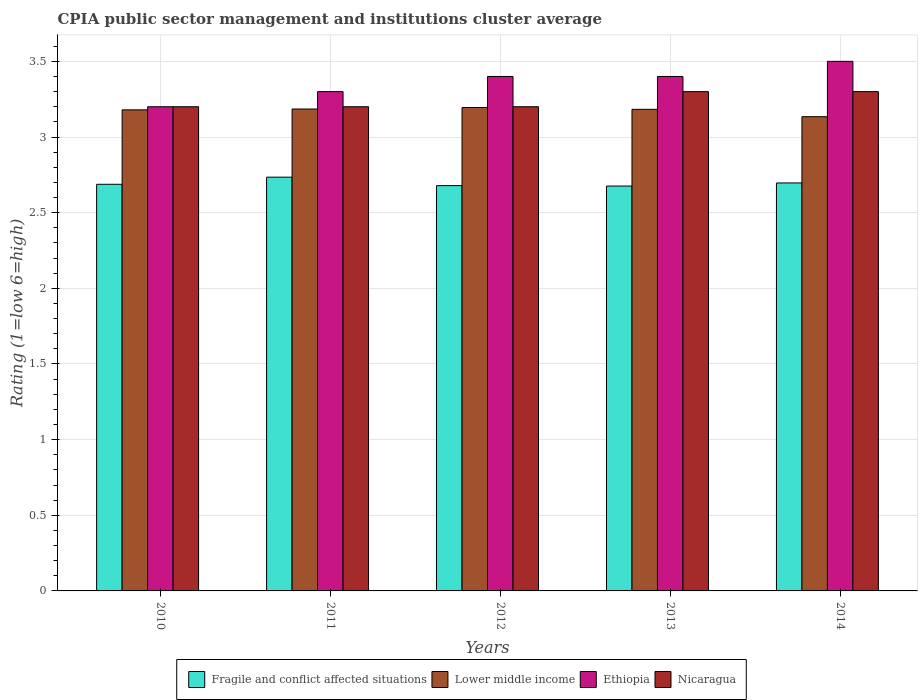How many different coloured bars are there?
Offer a very short reply. 4. How many groups of bars are there?
Offer a terse response. 5. Are the number of bars on each tick of the X-axis equal?
Your answer should be very brief. Yes. What is the CPIA rating in Fragile and conflict affected situations in 2011?
Provide a succinct answer. 2.73. In which year was the CPIA rating in Ethiopia minimum?
Your answer should be very brief. 2010. What is the total CPIA rating in Fragile and conflict affected situations in the graph?
Make the answer very short. 13.47. What is the difference between the CPIA rating in Lower middle income in 2010 and that in 2011?
Your answer should be compact. -0.01. What is the difference between the CPIA rating in Lower middle income in 2014 and the CPIA rating in Fragile and conflict affected situations in 2013?
Your answer should be very brief. 0.46. What is the average CPIA rating in Lower middle income per year?
Provide a short and direct response. 3.18. In the year 2012, what is the difference between the CPIA rating in Fragile and conflict affected situations and CPIA rating in Ethiopia?
Your answer should be very brief. -0.72. In how many years, is the CPIA rating in Ethiopia greater than 2.5?
Provide a short and direct response. 5. What is the ratio of the CPIA rating in Ethiopia in 2011 to that in 2014?
Offer a very short reply. 0.94. Is the CPIA rating in Lower middle income in 2010 less than that in 2013?
Provide a succinct answer. Yes. What is the difference between the highest and the lowest CPIA rating in Nicaragua?
Your response must be concise. 0.1. What does the 4th bar from the left in 2010 represents?
Make the answer very short. Nicaragua. What does the 4th bar from the right in 2012 represents?
Give a very brief answer. Fragile and conflict affected situations. Is it the case that in every year, the sum of the CPIA rating in Fragile and conflict affected situations and CPIA rating in Nicaragua is greater than the CPIA rating in Ethiopia?
Your answer should be very brief. Yes. How many years are there in the graph?
Keep it short and to the point. 5. Are the values on the major ticks of Y-axis written in scientific E-notation?
Provide a succinct answer. No. Does the graph contain grids?
Your answer should be compact. Yes. Where does the legend appear in the graph?
Offer a very short reply. Bottom center. How are the legend labels stacked?
Ensure brevity in your answer.  Horizontal. What is the title of the graph?
Your response must be concise. CPIA public sector management and institutions cluster average. What is the label or title of the X-axis?
Offer a terse response. Years. What is the Rating (1=low 6=high) of Fragile and conflict affected situations in 2010?
Give a very brief answer. 2.69. What is the Rating (1=low 6=high) of Lower middle income in 2010?
Offer a terse response. 3.18. What is the Rating (1=low 6=high) of Ethiopia in 2010?
Offer a terse response. 3.2. What is the Rating (1=low 6=high) of Nicaragua in 2010?
Your answer should be very brief. 3.2. What is the Rating (1=low 6=high) in Fragile and conflict affected situations in 2011?
Offer a very short reply. 2.73. What is the Rating (1=low 6=high) in Lower middle income in 2011?
Provide a short and direct response. 3.19. What is the Rating (1=low 6=high) of Ethiopia in 2011?
Your answer should be very brief. 3.3. What is the Rating (1=low 6=high) of Fragile and conflict affected situations in 2012?
Keep it short and to the point. 2.68. What is the Rating (1=low 6=high) of Lower middle income in 2012?
Give a very brief answer. 3.19. What is the Rating (1=low 6=high) of Nicaragua in 2012?
Your answer should be very brief. 3.2. What is the Rating (1=low 6=high) of Fragile and conflict affected situations in 2013?
Your answer should be very brief. 2.68. What is the Rating (1=low 6=high) of Lower middle income in 2013?
Ensure brevity in your answer.  3.18. What is the Rating (1=low 6=high) of Ethiopia in 2013?
Your answer should be very brief. 3.4. What is the Rating (1=low 6=high) in Fragile and conflict affected situations in 2014?
Your answer should be very brief. 2.7. What is the Rating (1=low 6=high) in Lower middle income in 2014?
Provide a succinct answer. 3.13. What is the Rating (1=low 6=high) of Ethiopia in 2014?
Keep it short and to the point. 3.5. Across all years, what is the maximum Rating (1=low 6=high) in Fragile and conflict affected situations?
Your response must be concise. 2.73. Across all years, what is the maximum Rating (1=low 6=high) in Lower middle income?
Offer a very short reply. 3.19. Across all years, what is the maximum Rating (1=low 6=high) of Ethiopia?
Provide a succinct answer. 3.5. Across all years, what is the maximum Rating (1=low 6=high) in Nicaragua?
Make the answer very short. 3.3. Across all years, what is the minimum Rating (1=low 6=high) of Fragile and conflict affected situations?
Give a very brief answer. 2.68. Across all years, what is the minimum Rating (1=low 6=high) of Lower middle income?
Your answer should be very brief. 3.13. Across all years, what is the minimum Rating (1=low 6=high) in Ethiopia?
Give a very brief answer. 3.2. What is the total Rating (1=low 6=high) of Fragile and conflict affected situations in the graph?
Ensure brevity in your answer.  13.47. What is the total Rating (1=low 6=high) in Lower middle income in the graph?
Give a very brief answer. 15.88. What is the total Rating (1=low 6=high) of Ethiopia in the graph?
Provide a short and direct response. 16.8. What is the total Rating (1=low 6=high) in Nicaragua in the graph?
Your answer should be compact. 16.2. What is the difference between the Rating (1=low 6=high) of Fragile and conflict affected situations in 2010 and that in 2011?
Your answer should be compact. -0.05. What is the difference between the Rating (1=low 6=high) of Lower middle income in 2010 and that in 2011?
Offer a terse response. -0.01. What is the difference between the Rating (1=low 6=high) in Ethiopia in 2010 and that in 2011?
Offer a very short reply. -0.1. What is the difference between the Rating (1=low 6=high) in Nicaragua in 2010 and that in 2011?
Your answer should be compact. 0. What is the difference between the Rating (1=low 6=high) of Fragile and conflict affected situations in 2010 and that in 2012?
Your answer should be very brief. 0.01. What is the difference between the Rating (1=low 6=high) of Lower middle income in 2010 and that in 2012?
Your response must be concise. -0.02. What is the difference between the Rating (1=low 6=high) in Ethiopia in 2010 and that in 2012?
Make the answer very short. -0.2. What is the difference between the Rating (1=low 6=high) in Fragile and conflict affected situations in 2010 and that in 2013?
Your response must be concise. 0.01. What is the difference between the Rating (1=low 6=high) of Lower middle income in 2010 and that in 2013?
Your answer should be very brief. -0. What is the difference between the Rating (1=low 6=high) in Ethiopia in 2010 and that in 2013?
Your response must be concise. -0.2. What is the difference between the Rating (1=low 6=high) of Fragile and conflict affected situations in 2010 and that in 2014?
Your answer should be very brief. -0.01. What is the difference between the Rating (1=low 6=high) in Lower middle income in 2010 and that in 2014?
Ensure brevity in your answer.  0.05. What is the difference between the Rating (1=low 6=high) in Ethiopia in 2010 and that in 2014?
Keep it short and to the point. -0.3. What is the difference between the Rating (1=low 6=high) in Nicaragua in 2010 and that in 2014?
Provide a short and direct response. -0.1. What is the difference between the Rating (1=low 6=high) in Fragile and conflict affected situations in 2011 and that in 2012?
Your response must be concise. 0.06. What is the difference between the Rating (1=low 6=high) in Lower middle income in 2011 and that in 2012?
Offer a terse response. -0.01. What is the difference between the Rating (1=low 6=high) in Nicaragua in 2011 and that in 2012?
Your answer should be compact. 0. What is the difference between the Rating (1=low 6=high) in Fragile and conflict affected situations in 2011 and that in 2013?
Offer a very short reply. 0.06. What is the difference between the Rating (1=low 6=high) in Lower middle income in 2011 and that in 2013?
Provide a short and direct response. 0. What is the difference between the Rating (1=low 6=high) of Fragile and conflict affected situations in 2011 and that in 2014?
Offer a very short reply. 0.04. What is the difference between the Rating (1=low 6=high) of Lower middle income in 2011 and that in 2014?
Your response must be concise. 0.05. What is the difference between the Rating (1=low 6=high) in Ethiopia in 2011 and that in 2014?
Your answer should be compact. -0.2. What is the difference between the Rating (1=low 6=high) in Nicaragua in 2011 and that in 2014?
Give a very brief answer. -0.1. What is the difference between the Rating (1=low 6=high) in Fragile and conflict affected situations in 2012 and that in 2013?
Your answer should be compact. 0. What is the difference between the Rating (1=low 6=high) of Lower middle income in 2012 and that in 2013?
Offer a terse response. 0.01. What is the difference between the Rating (1=low 6=high) of Ethiopia in 2012 and that in 2013?
Your response must be concise. 0. What is the difference between the Rating (1=low 6=high) in Fragile and conflict affected situations in 2012 and that in 2014?
Your answer should be very brief. -0.02. What is the difference between the Rating (1=low 6=high) of Lower middle income in 2012 and that in 2014?
Your answer should be very brief. 0.06. What is the difference between the Rating (1=low 6=high) of Nicaragua in 2012 and that in 2014?
Provide a succinct answer. -0.1. What is the difference between the Rating (1=low 6=high) of Fragile and conflict affected situations in 2013 and that in 2014?
Ensure brevity in your answer.  -0.02. What is the difference between the Rating (1=low 6=high) in Lower middle income in 2013 and that in 2014?
Provide a short and direct response. 0.05. What is the difference between the Rating (1=low 6=high) in Ethiopia in 2013 and that in 2014?
Provide a succinct answer. -0.1. What is the difference between the Rating (1=low 6=high) of Fragile and conflict affected situations in 2010 and the Rating (1=low 6=high) of Lower middle income in 2011?
Your answer should be compact. -0.5. What is the difference between the Rating (1=low 6=high) in Fragile and conflict affected situations in 2010 and the Rating (1=low 6=high) in Ethiopia in 2011?
Provide a succinct answer. -0.61. What is the difference between the Rating (1=low 6=high) of Fragile and conflict affected situations in 2010 and the Rating (1=low 6=high) of Nicaragua in 2011?
Give a very brief answer. -0.51. What is the difference between the Rating (1=low 6=high) of Lower middle income in 2010 and the Rating (1=low 6=high) of Ethiopia in 2011?
Keep it short and to the point. -0.12. What is the difference between the Rating (1=low 6=high) in Lower middle income in 2010 and the Rating (1=low 6=high) in Nicaragua in 2011?
Ensure brevity in your answer.  -0.02. What is the difference between the Rating (1=low 6=high) in Ethiopia in 2010 and the Rating (1=low 6=high) in Nicaragua in 2011?
Make the answer very short. 0. What is the difference between the Rating (1=low 6=high) in Fragile and conflict affected situations in 2010 and the Rating (1=low 6=high) in Lower middle income in 2012?
Offer a terse response. -0.51. What is the difference between the Rating (1=low 6=high) in Fragile and conflict affected situations in 2010 and the Rating (1=low 6=high) in Ethiopia in 2012?
Provide a succinct answer. -0.71. What is the difference between the Rating (1=low 6=high) of Fragile and conflict affected situations in 2010 and the Rating (1=low 6=high) of Nicaragua in 2012?
Provide a short and direct response. -0.51. What is the difference between the Rating (1=low 6=high) of Lower middle income in 2010 and the Rating (1=low 6=high) of Ethiopia in 2012?
Keep it short and to the point. -0.22. What is the difference between the Rating (1=low 6=high) in Lower middle income in 2010 and the Rating (1=low 6=high) in Nicaragua in 2012?
Provide a succinct answer. -0.02. What is the difference between the Rating (1=low 6=high) in Ethiopia in 2010 and the Rating (1=low 6=high) in Nicaragua in 2012?
Make the answer very short. 0. What is the difference between the Rating (1=low 6=high) in Fragile and conflict affected situations in 2010 and the Rating (1=low 6=high) in Lower middle income in 2013?
Keep it short and to the point. -0.5. What is the difference between the Rating (1=low 6=high) in Fragile and conflict affected situations in 2010 and the Rating (1=low 6=high) in Ethiopia in 2013?
Your answer should be compact. -0.71. What is the difference between the Rating (1=low 6=high) of Fragile and conflict affected situations in 2010 and the Rating (1=low 6=high) of Nicaragua in 2013?
Offer a terse response. -0.61. What is the difference between the Rating (1=low 6=high) of Lower middle income in 2010 and the Rating (1=low 6=high) of Ethiopia in 2013?
Provide a short and direct response. -0.22. What is the difference between the Rating (1=low 6=high) in Lower middle income in 2010 and the Rating (1=low 6=high) in Nicaragua in 2013?
Ensure brevity in your answer.  -0.12. What is the difference between the Rating (1=low 6=high) in Ethiopia in 2010 and the Rating (1=low 6=high) in Nicaragua in 2013?
Offer a very short reply. -0.1. What is the difference between the Rating (1=low 6=high) of Fragile and conflict affected situations in 2010 and the Rating (1=low 6=high) of Lower middle income in 2014?
Your answer should be very brief. -0.45. What is the difference between the Rating (1=low 6=high) in Fragile and conflict affected situations in 2010 and the Rating (1=low 6=high) in Ethiopia in 2014?
Keep it short and to the point. -0.81. What is the difference between the Rating (1=low 6=high) of Fragile and conflict affected situations in 2010 and the Rating (1=low 6=high) of Nicaragua in 2014?
Ensure brevity in your answer.  -0.61. What is the difference between the Rating (1=low 6=high) in Lower middle income in 2010 and the Rating (1=low 6=high) in Ethiopia in 2014?
Your answer should be compact. -0.32. What is the difference between the Rating (1=low 6=high) in Lower middle income in 2010 and the Rating (1=low 6=high) in Nicaragua in 2014?
Your answer should be very brief. -0.12. What is the difference between the Rating (1=low 6=high) in Fragile and conflict affected situations in 2011 and the Rating (1=low 6=high) in Lower middle income in 2012?
Your answer should be very brief. -0.46. What is the difference between the Rating (1=low 6=high) of Fragile and conflict affected situations in 2011 and the Rating (1=low 6=high) of Ethiopia in 2012?
Make the answer very short. -0.67. What is the difference between the Rating (1=low 6=high) in Fragile and conflict affected situations in 2011 and the Rating (1=low 6=high) in Nicaragua in 2012?
Provide a short and direct response. -0.47. What is the difference between the Rating (1=low 6=high) in Lower middle income in 2011 and the Rating (1=low 6=high) in Ethiopia in 2012?
Ensure brevity in your answer.  -0.21. What is the difference between the Rating (1=low 6=high) in Lower middle income in 2011 and the Rating (1=low 6=high) in Nicaragua in 2012?
Offer a very short reply. -0.01. What is the difference between the Rating (1=low 6=high) of Ethiopia in 2011 and the Rating (1=low 6=high) of Nicaragua in 2012?
Make the answer very short. 0.1. What is the difference between the Rating (1=low 6=high) in Fragile and conflict affected situations in 2011 and the Rating (1=low 6=high) in Lower middle income in 2013?
Provide a succinct answer. -0.45. What is the difference between the Rating (1=low 6=high) in Fragile and conflict affected situations in 2011 and the Rating (1=low 6=high) in Ethiopia in 2013?
Offer a terse response. -0.67. What is the difference between the Rating (1=low 6=high) of Fragile and conflict affected situations in 2011 and the Rating (1=low 6=high) of Nicaragua in 2013?
Make the answer very short. -0.57. What is the difference between the Rating (1=low 6=high) of Lower middle income in 2011 and the Rating (1=low 6=high) of Ethiopia in 2013?
Your response must be concise. -0.21. What is the difference between the Rating (1=low 6=high) of Lower middle income in 2011 and the Rating (1=low 6=high) of Nicaragua in 2013?
Your answer should be very brief. -0.12. What is the difference between the Rating (1=low 6=high) in Fragile and conflict affected situations in 2011 and the Rating (1=low 6=high) in Lower middle income in 2014?
Ensure brevity in your answer.  -0.4. What is the difference between the Rating (1=low 6=high) of Fragile and conflict affected situations in 2011 and the Rating (1=low 6=high) of Ethiopia in 2014?
Offer a terse response. -0.77. What is the difference between the Rating (1=low 6=high) in Fragile and conflict affected situations in 2011 and the Rating (1=low 6=high) in Nicaragua in 2014?
Ensure brevity in your answer.  -0.57. What is the difference between the Rating (1=low 6=high) in Lower middle income in 2011 and the Rating (1=low 6=high) in Ethiopia in 2014?
Keep it short and to the point. -0.32. What is the difference between the Rating (1=low 6=high) of Lower middle income in 2011 and the Rating (1=low 6=high) of Nicaragua in 2014?
Offer a very short reply. -0.12. What is the difference between the Rating (1=low 6=high) of Ethiopia in 2011 and the Rating (1=low 6=high) of Nicaragua in 2014?
Provide a short and direct response. 0. What is the difference between the Rating (1=low 6=high) of Fragile and conflict affected situations in 2012 and the Rating (1=low 6=high) of Lower middle income in 2013?
Your answer should be compact. -0.5. What is the difference between the Rating (1=low 6=high) in Fragile and conflict affected situations in 2012 and the Rating (1=low 6=high) in Ethiopia in 2013?
Your response must be concise. -0.72. What is the difference between the Rating (1=low 6=high) of Fragile and conflict affected situations in 2012 and the Rating (1=low 6=high) of Nicaragua in 2013?
Make the answer very short. -0.62. What is the difference between the Rating (1=low 6=high) in Lower middle income in 2012 and the Rating (1=low 6=high) in Ethiopia in 2013?
Offer a very short reply. -0.2. What is the difference between the Rating (1=low 6=high) in Lower middle income in 2012 and the Rating (1=low 6=high) in Nicaragua in 2013?
Make the answer very short. -0.1. What is the difference between the Rating (1=low 6=high) of Fragile and conflict affected situations in 2012 and the Rating (1=low 6=high) of Lower middle income in 2014?
Make the answer very short. -0.46. What is the difference between the Rating (1=low 6=high) in Fragile and conflict affected situations in 2012 and the Rating (1=low 6=high) in Ethiopia in 2014?
Provide a short and direct response. -0.82. What is the difference between the Rating (1=low 6=high) in Fragile and conflict affected situations in 2012 and the Rating (1=low 6=high) in Nicaragua in 2014?
Offer a terse response. -0.62. What is the difference between the Rating (1=low 6=high) of Lower middle income in 2012 and the Rating (1=low 6=high) of Ethiopia in 2014?
Provide a short and direct response. -0.3. What is the difference between the Rating (1=low 6=high) in Lower middle income in 2012 and the Rating (1=low 6=high) in Nicaragua in 2014?
Keep it short and to the point. -0.1. What is the difference between the Rating (1=low 6=high) of Fragile and conflict affected situations in 2013 and the Rating (1=low 6=high) of Lower middle income in 2014?
Your answer should be very brief. -0.46. What is the difference between the Rating (1=low 6=high) of Fragile and conflict affected situations in 2013 and the Rating (1=low 6=high) of Ethiopia in 2014?
Ensure brevity in your answer.  -0.82. What is the difference between the Rating (1=low 6=high) of Fragile and conflict affected situations in 2013 and the Rating (1=low 6=high) of Nicaragua in 2014?
Your response must be concise. -0.62. What is the difference between the Rating (1=low 6=high) in Lower middle income in 2013 and the Rating (1=low 6=high) in Ethiopia in 2014?
Your answer should be very brief. -0.32. What is the difference between the Rating (1=low 6=high) of Lower middle income in 2013 and the Rating (1=low 6=high) of Nicaragua in 2014?
Provide a succinct answer. -0.12. What is the difference between the Rating (1=low 6=high) in Ethiopia in 2013 and the Rating (1=low 6=high) in Nicaragua in 2014?
Offer a terse response. 0.1. What is the average Rating (1=low 6=high) of Fragile and conflict affected situations per year?
Offer a very short reply. 2.69. What is the average Rating (1=low 6=high) in Lower middle income per year?
Offer a terse response. 3.18. What is the average Rating (1=low 6=high) of Ethiopia per year?
Your answer should be compact. 3.36. What is the average Rating (1=low 6=high) in Nicaragua per year?
Give a very brief answer. 3.24. In the year 2010, what is the difference between the Rating (1=low 6=high) of Fragile and conflict affected situations and Rating (1=low 6=high) of Lower middle income?
Your response must be concise. -0.49. In the year 2010, what is the difference between the Rating (1=low 6=high) in Fragile and conflict affected situations and Rating (1=low 6=high) in Ethiopia?
Give a very brief answer. -0.51. In the year 2010, what is the difference between the Rating (1=low 6=high) in Fragile and conflict affected situations and Rating (1=low 6=high) in Nicaragua?
Provide a short and direct response. -0.51. In the year 2010, what is the difference between the Rating (1=low 6=high) of Lower middle income and Rating (1=low 6=high) of Ethiopia?
Keep it short and to the point. -0.02. In the year 2010, what is the difference between the Rating (1=low 6=high) of Lower middle income and Rating (1=low 6=high) of Nicaragua?
Offer a terse response. -0.02. In the year 2010, what is the difference between the Rating (1=low 6=high) in Ethiopia and Rating (1=low 6=high) in Nicaragua?
Keep it short and to the point. 0. In the year 2011, what is the difference between the Rating (1=low 6=high) of Fragile and conflict affected situations and Rating (1=low 6=high) of Lower middle income?
Your response must be concise. -0.45. In the year 2011, what is the difference between the Rating (1=low 6=high) in Fragile and conflict affected situations and Rating (1=low 6=high) in Ethiopia?
Ensure brevity in your answer.  -0.57. In the year 2011, what is the difference between the Rating (1=low 6=high) in Fragile and conflict affected situations and Rating (1=low 6=high) in Nicaragua?
Offer a very short reply. -0.47. In the year 2011, what is the difference between the Rating (1=low 6=high) of Lower middle income and Rating (1=low 6=high) of Ethiopia?
Provide a short and direct response. -0.12. In the year 2011, what is the difference between the Rating (1=low 6=high) in Lower middle income and Rating (1=low 6=high) in Nicaragua?
Ensure brevity in your answer.  -0.01. In the year 2012, what is the difference between the Rating (1=low 6=high) of Fragile and conflict affected situations and Rating (1=low 6=high) of Lower middle income?
Provide a short and direct response. -0.52. In the year 2012, what is the difference between the Rating (1=low 6=high) of Fragile and conflict affected situations and Rating (1=low 6=high) of Ethiopia?
Provide a short and direct response. -0.72. In the year 2012, what is the difference between the Rating (1=low 6=high) in Fragile and conflict affected situations and Rating (1=low 6=high) in Nicaragua?
Keep it short and to the point. -0.52. In the year 2012, what is the difference between the Rating (1=low 6=high) in Lower middle income and Rating (1=low 6=high) in Ethiopia?
Keep it short and to the point. -0.2. In the year 2012, what is the difference between the Rating (1=low 6=high) in Lower middle income and Rating (1=low 6=high) in Nicaragua?
Provide a succinct answer. -0.01. In the year 2012, what is the difference between the Rating (1=low 6=high) in Ethiopia and Rating (1=low 6=high) in Nicaragua?
Keep it short and to the point. 0.2. In the year 2013, what is the difference between the Rating (1=low 6=high) in Fragile and conflict affected situations and Rating (1=low 6=high) in Lower middle income?
Your answer should be very brief. -0.51. In the year 2013, what is the difference between the Rating (1=low 6=high) of Fragile and conflict affected situations and Rating (1=low 6=high) of Ethiopia?
Ensure brevity in your answer.  -0.72. In the year 2013, what is the difference between the Rating (1=low 6=high) of Fragile and conflict affected situations and Rating (1=low 6=high) of Nicaragua?
Your answer should be very brief. -0.62. In the year 2013, what is the difference between the Rating (1=low 6=high) in Lower middle income and Rating (1=low 6=high) in Ethiopia?
Keep it short and to the point. -0.22. In the year 2013, what is the difference between the Rating (1=low 6=high) of Lower middle income and Rating (1=low 6=high) of Nicaragua?
Give a very brief answer. -0.12. In the year 2014, what is the difference between the Rating (1=low 6=high) of Fragile and conflict affected situations and Rating (1=low 6=high) of Lower middle income?
Your answer should be compact. -0.44. In the year 2014, what is the difference between the Rating (1=low 6=high) in Fragile and conflict affected situations and Rating (1=low 6=high) in Ethiopia?
Offer a very short reply. -0.8. In the year 2014, what is the difference between the Rating (1=low 6=high) in Fragile and conflict affected situations and Rating (1=low 6=high) in Nicaragua?
Your response must be concise. -0.6. In the year 2014, what is the difference between the Rating (1=low 6=high) of Lower middle income and Rating (1=low 6=high) of Ethiopia?
Your answer should be compact. -0.37. In the year 2014, what is the difference between the Rating (1=low 6=high) of Lower middle income and Rating (1=low 6=high) of Nicaragua?
Offer a very short reply. -0.17. In the year 2014, what is the difference between the Rating (1=low 6=high) in Ethiopia and Rating (1=low 6=high) in Nicaragua?
Offer a very short reply. 0.2. What is the ratio of the Rating (1=low 6=high) of Fragile and conflict affected situations in 2010 to that in 2011?
Make the answer very short. 0.98. What is the ratio of the Rating (1=low 6=high) of Ethiopia in 2010 to that in 2011?
Provide a succinct answer. 0.97. What is the ratio of the Rating (1=low 6=high) in Ethiopia in 2010 to that in 2012?
Give a very brief answer. 0.94. What is the ratio of the Rating (1=low 6=high) of Nicaragua in 2010 to that in 2013?
Keep it short and to the point. 0.97. What is the ratio of the Rating (1=low 6=high) in Fragile and conflict affected situations in 2010 to that in 2014?
Make the answer very short. 1. What is the ratio of the Rating (1=low 6=high) in Lower middle income in 2010 to that in 2014?
Provide a succinct answer. 1.01. What is the ratio of the Rating (1=low 6=high) in Ethiopia in 2010 to that in 2014?
Offer a very short reply. 0.91. What is the ratio of the Rating (1=low 6=high) in Nicaragua in 2010 to that in 2014?
Make the answer very short. 0.97. What is the ratio of the Rating (1=low 6=high) of Fragile and conflict affected situations in 2011 to that in 2012?
Your answer should be very brief. 1.02. What is the ratio of the Rating (1=low 6=high) of Ethiopia in 2011 to that in 2012?
Offer a very short reply. 0.97. What is the ratio of the Rating (1=low 6=high) of Fragile and conflict affected situations in 2011 to that in 2013?
Keep it short and to the point. 1.02. What is the ratio of the Rating (1=low 6=high) in Lower middle income in 2011 to that in 2013?
Offer a very short reply. 1. What is the ratio of the Rating (1=low 6=high) in Ethiopia in 2011 to that in 2013?
Provide a short and direct response. 0.97. What is the ratio of the Rating (1=low 6=high) of Nicaragua in 2011 to that in 2013?
Offer a very short reply. 0.97. What is the ratio of the Rating (1=low 6=high) in Fragile and conflict affected situations in 2011 to that in 2014?
Your answer should be compact. 1.01. What is the ratio of the Rating (1=low 6=high) of Lower middle income in 2011 to that in 2014?
Your response must be concise. 1.02. What is the ratio of the Rating (1=low 6=high) in Ethiopia in 2011 to that in 2014?
Make the answer very short. 0.94. What is the ratio of the Rating (1=low 6=high) in Nicaragua in 2011 to that in 2014?
Your answer should be compact. 0.97. What is the ratio of the Rating (1=low 6=high) of Ethiopia in 2012 to that in 2013?
Provide a short and direct response. 1. What is the ratio of the Rating (1=low 6=high) of Nicaragua in 2012 to that in 2013?
Offer a terse response. 0.97. What is the ratio of the Rating (1=low 6=high) in Fragile and conflict affected situations in 2012 to that in 2014?
Offer a very short reply. 0.99. What is the ratio of the Rating (1=low 6=high) in Lower middle income in 2012 to that in 2014?
Ensure brevity in your answer.  1.02. What is the ratio of the Rating (1=low 6=high) in Ethiopia in 2012 to that in 2014?
Provide a succinct answer. 0.97. What is the ratio of the Rating (1=low 6=high) of Nicaragua in 2012 to that in 2014?
Your answer should be compact. 0.97. What is the ratio of the Rating (1=low 6=high) of Lower middle income in 2013 to that in 2014?
Provide a short and direct response. 1.02. What is the ratio of the Rating (1=low 6=high) of Ethiopia in 2013 to that in 2014?
Keep it short and to the point. 0.97. What is the difference between the highest and the second highest Rating (1=low 6=high) of Fragile and conflict affected situations?
Your answer should be very brief. 0.04. What is the difference between the highest and the second highest Rating (1=low 6=high) of Ethiopia?
Provide a succinct answer. 0.1. What is the difference between the highest and the second highest Rating (1=low 6=high) of Nicaragua?
Make the answer very short. 0. What is the difference between the highest and the lowest Rating (1=low 6=high) in Fragile and conflict affected situations?
Offer a very short reply. 0.06. What is the difference between the highest and the lowest Rating (1=low 6=high) of Lower middle income?
Provide a succinct answer. 0.06. What is the difference between the highest and the lowest Rating (1=low 6=high) of Ethiopia?
Ensure brevity in your answer.  0.3. What is the difference between the highest and the lowest Rating (1=low 6=high) of Nicaragua?
Provide a short and direct response. 0.1. 